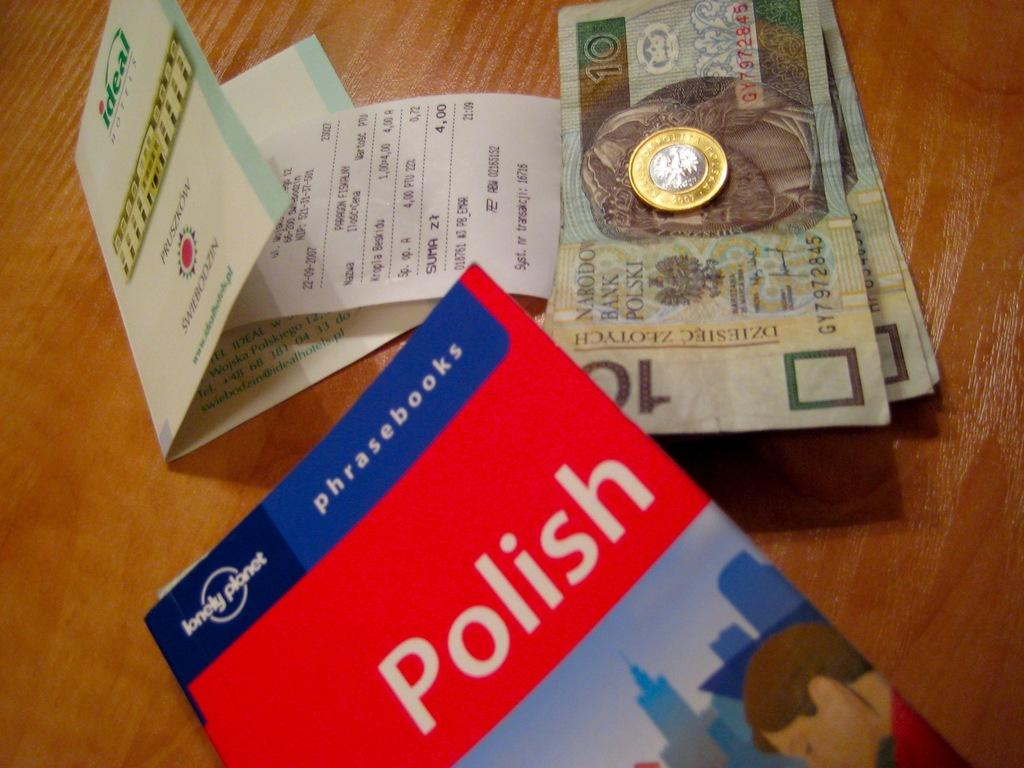<image>
Give a short and clear explanation of the subsequent image. Some currency with a book for Polish learning 